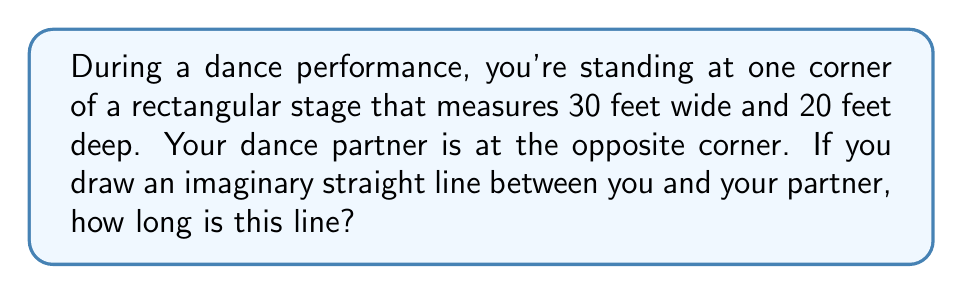Provide a solution to this math problem. Let's solve this step-by-step:

1) This problem can be solved using the Pythagorean theorem. The stage forms a right triangle where:
   - The width of the stage is one side (a)
   - The depth of the stage is another side (b)
   - The line between the dancers is the hypotenuse (c)

2) We know:
   a = 30 feet (width)
   b = 20 feet (depth)

3) The Pythagorean theorem states: $a^2 + b^2 = c^2$

4) Let's substitute our known values:
   $30^2 + 20^2 = c^2$

5) Simplify:
   $900 + 400 = c^2$
   $1300 = c^2$

6) To find c, we need to take the square root of both sides:
   $\sqrt{1300} = c$

7) Simplify:
   $c \approx 36.06$ feet

Therefore, the distance between you and your dance partner is approximately 36.06 feet.
Answer: 36.06 feet 